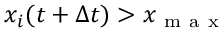Convert formula to latex. <formula><loc_0><loc_0><loc_500><loc_500>x _ { i } ( t + \Delta t ) > x _ { m a x }</formula> 